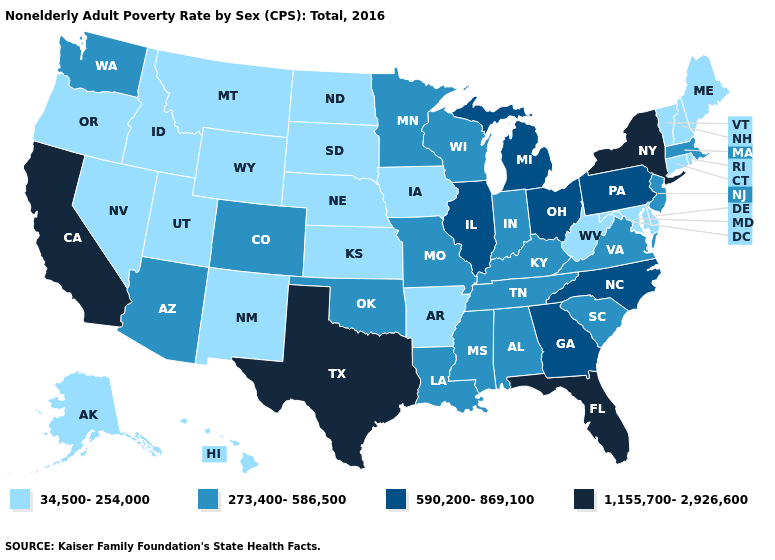Name the states that have a value in the range 34,500-254,000?
Answer briefly. Alaska, Arkansas, Connecticut, Delaware, Hawaii, Idaho, Iowa, Kansas, Maine, Maryland, Montana, Nebraska, Nevada, New Hampshire, New Mexico, North Dakota, Oregon, Rhode Island, South Dakota, Utah, Vermont, West Virginia, Wyoming. What is the value of Indiana?
Quick response, please. 273,400-586,500. Name the states that have a value in the range 1,155,700-2,926,600?
Concise answer only. California, Florida, New York, Texas. Does Washington have the same value as West Virginia?
Answer briefly. No. Name the states that have a value in the range 590,200-869,100?
Keep it brief. Georgia, Illinois, Michigan, North Carolina, Ohio, Pennsylvania. What is the lowest value in the USA?
Answer briefly. 34,500-254,000. What is the value of Illinois?
Answer briefly. 590,200-869,100. What is the lowest value in states that border Maine?
Quick response, please. 34,500-254,000. Does the first symbol in the legend represent the smallest category?
Write a very short answer. Yes. What is the value of South Dakota?
Keep it brief. 34,500-254,000. What is the value of Indiana?
Quick response, please. 273,400-586,500. What is the lowest value in the USA?
Give a very brief answer. 34,500-254,000. What is the value of New Hampshire?
Concise answer only. 34,500-254,000. What is the lowest value in states that border New Jersey?
Answer briefly. 34,500-254,000. What is the highest value in the South ?
Write a very short answer. 1,155,700-2,926,600. 